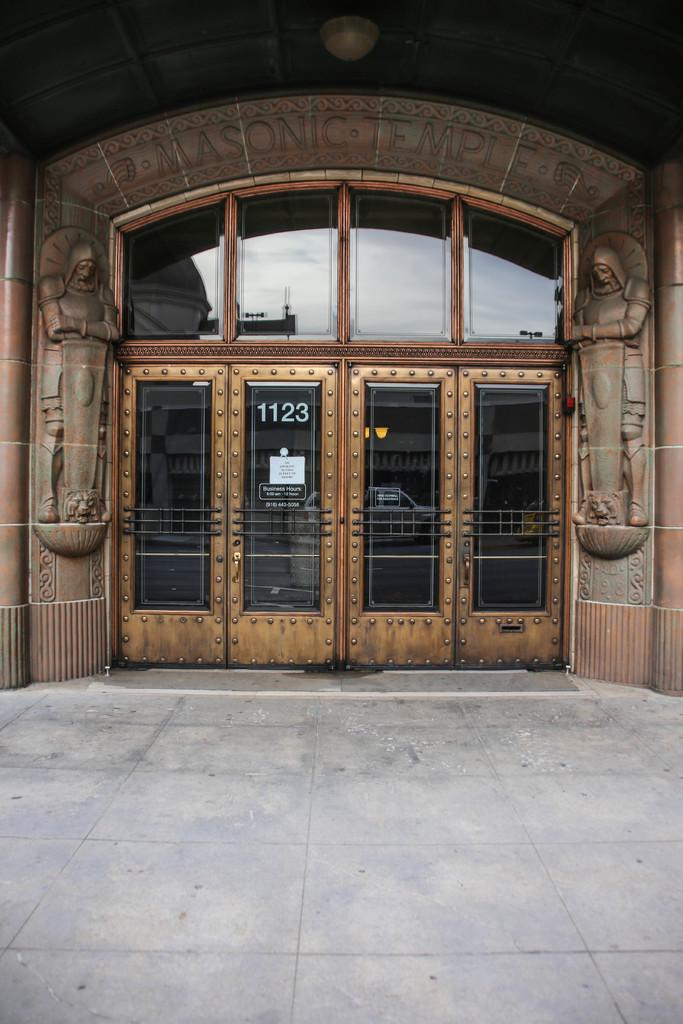What type of structure is present in the image? There is a building in the image. What is the color of the building? The building is brown in color. What type of doors are on the building? There are glass doors on the building. What type of windows are on the building? There are glass windows on the building. Can you tell me how many times the person in the image smiles? There is no person present in the image, so it is not possible to determine how many times they smile. 